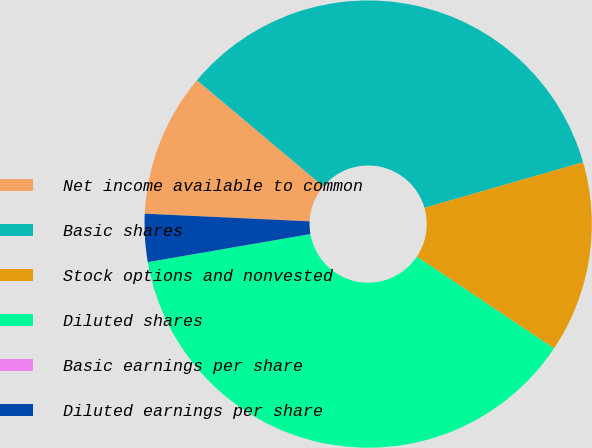Convert chart to OTSL. <chart><loc_0><loc_0><loc_500><loc_500><pie_chart><fcel>Net income available to common<fcel>Basic shares<fcel>Stock options and nonvested<fcel>Diluted shares<fcel>Basic earnings per share<fcel>Diluted earnings per share<nl><fcel>10.38%<fcel>34.42%<fcel>13.84%<fcel>37.89%<fcel>0.0%<fcel>3.46%<nl></chart> 